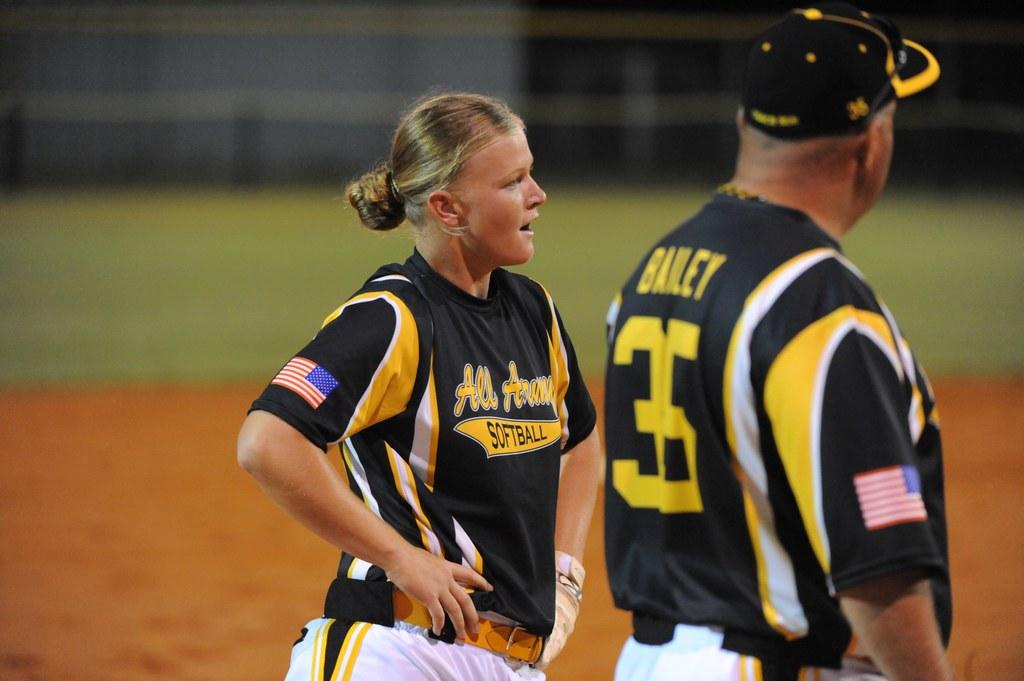<image>
Write a terse but informative summary of the picture. The man on the right has the number 35 on his jersey 